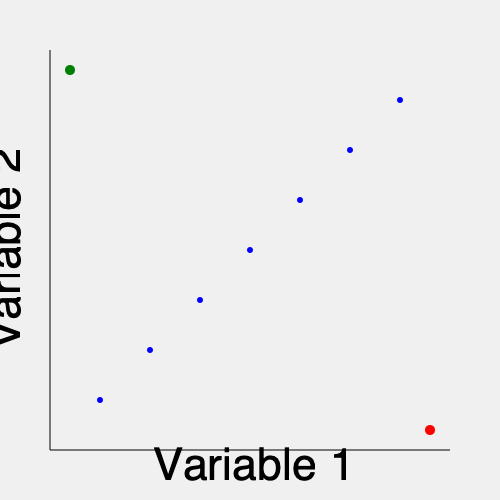In the given high-dimensional scatterplot matrix representation, identify the outlier and the influential point. Explain how these points differ in their impact on statistical analyses, particularly in the context of regression modeling. How would you recommend handling each type of point in a real-world data analysis scenario? To identify outliers and influential points in a high-dimensional scatterplot matrix, we need to consider their characteristics and impacts:

1. Outlier identification:
   - An outlier is a data point that significantly deviates from the overall pattern of the data.
   - In the scatterplot, the red point at (380, 380) is clearly an outlier as it lies far from the main cluster of points.

2. Influential point identification:
   - An influential point is a data point that has a disproportionate impact on the statistical analysis, particularly in regression modeling.
   - The green point at (20, 20) is likely an influential point as it is isolated from the main cluster and positioned at an extreme end of the distribution.

3. Impact on statistical analyses:
   - Outliers:
     - Can significantly affect measures of central tendency and dispersion.
     - May lead to biased parameter estimates in regression models.
     - Can inflate standard errors and reduce the power of statistical tests.
   - Influential points:
     - Have a substantial impact on the slope and intercept of regression lines.
     - Can dramatically change the results of hypothesis tests and confidence intervals.
     - May lead to incorrect conclusions about the relationships between variables.

4. Handling outliers and influential points:
   a. For outliers:
      - Investigate the cause of the outlier (e.g., data entry error, measurement error).
      - If it's a valid data point, consider robust statistical methods that are less sensitive to outliers.
      - In some cases, it may be appropriate to remove the outlier, but this should be done with caution and transparently reported.

   b. For influential points:
      - Examine the point's leverage (its distance from the mean of the predictor variables) and its residual.
      - Use diagnostic measures like Cook's distance or DFFITS to quantify the point's influence.
      - Consider running analyses with and without the influential point to assess its impact on the results.
      - If the point is valid, report results both including and excluding it, discussing the implications of each scenario.

5. Real-world recommendation:
   - Always investigate the source and validity of outliers and influential points before deciding on a course of action.
   - Use multiple diagnostic tools and visualizations to identify these points in high-dimensional data.
   - Consider the context of the data and the research question when deciding how to handle these points.
   - Be transparent in reporting how outliers and influential points were identified and handled in the analysis.
   - When possible, collect additional data or conduct follow-up studies to better understand the nature of these unusual observations.

By carefully considering these factors, statisticians can make informed decisions about how to handle outliers and influential points in their analyses, ensuring the robustness and reliability of their results.
Answer: Outlier: red point (380, 380); Influential point: green point (20, 20). Outliers affect summary statistics; influential points impact regression coefficients. Handle with caution: investigate causes, use robust methods, and report transparently. 